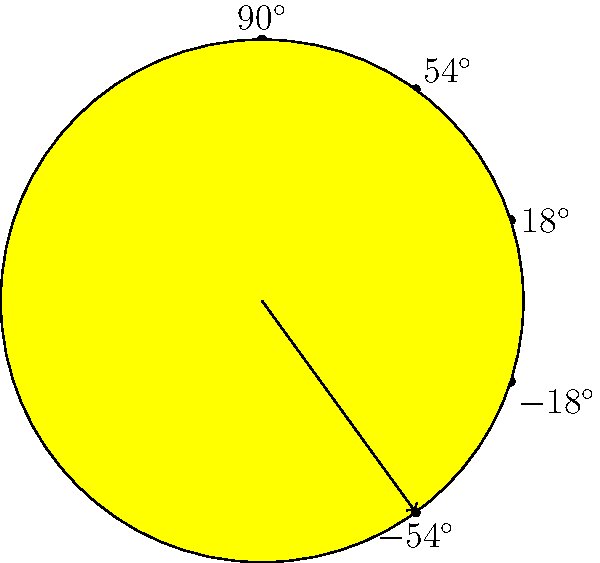In our online store's customer satisfaction rating system, we use a 5-star display. Each star is positioned at a specific angle from the vertical axis. If the topmost star is at $90^\circ$ and each subsequent star is rotated $36^\circ$ clockwise, what is the angle of the bottommost star from the vertical axis? Let's approach this step-by-step:

1) We start with the topmost star at $90^\circ$ from the vertical axis.

2) Each subsequent star is rotated $36^\circ$ clockwise. This means we subtract $36^\circ$ for each star.

3) For the second star: $90^\circ - 36^\circ = 54^\circ$

4) For the third star: $54^\circ - 36^\circ = 18^\circ$

5) For the fourth star: $18^\circ - 36^\circ = -18^\circ$

6) For the fifth (bottommost) star: $-18^\circ - 36^\circ = -54^\circ$

Therefore, the bottommost star is positioned at $-54^\circ$ from the vertical axis.
Answer: $-54^\circ$ 